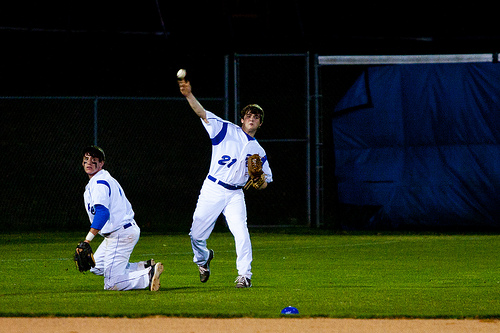What position might the standing player be playing? The standing player is likely the pitcher, judging by his stance and the motion of throwing the ball. 